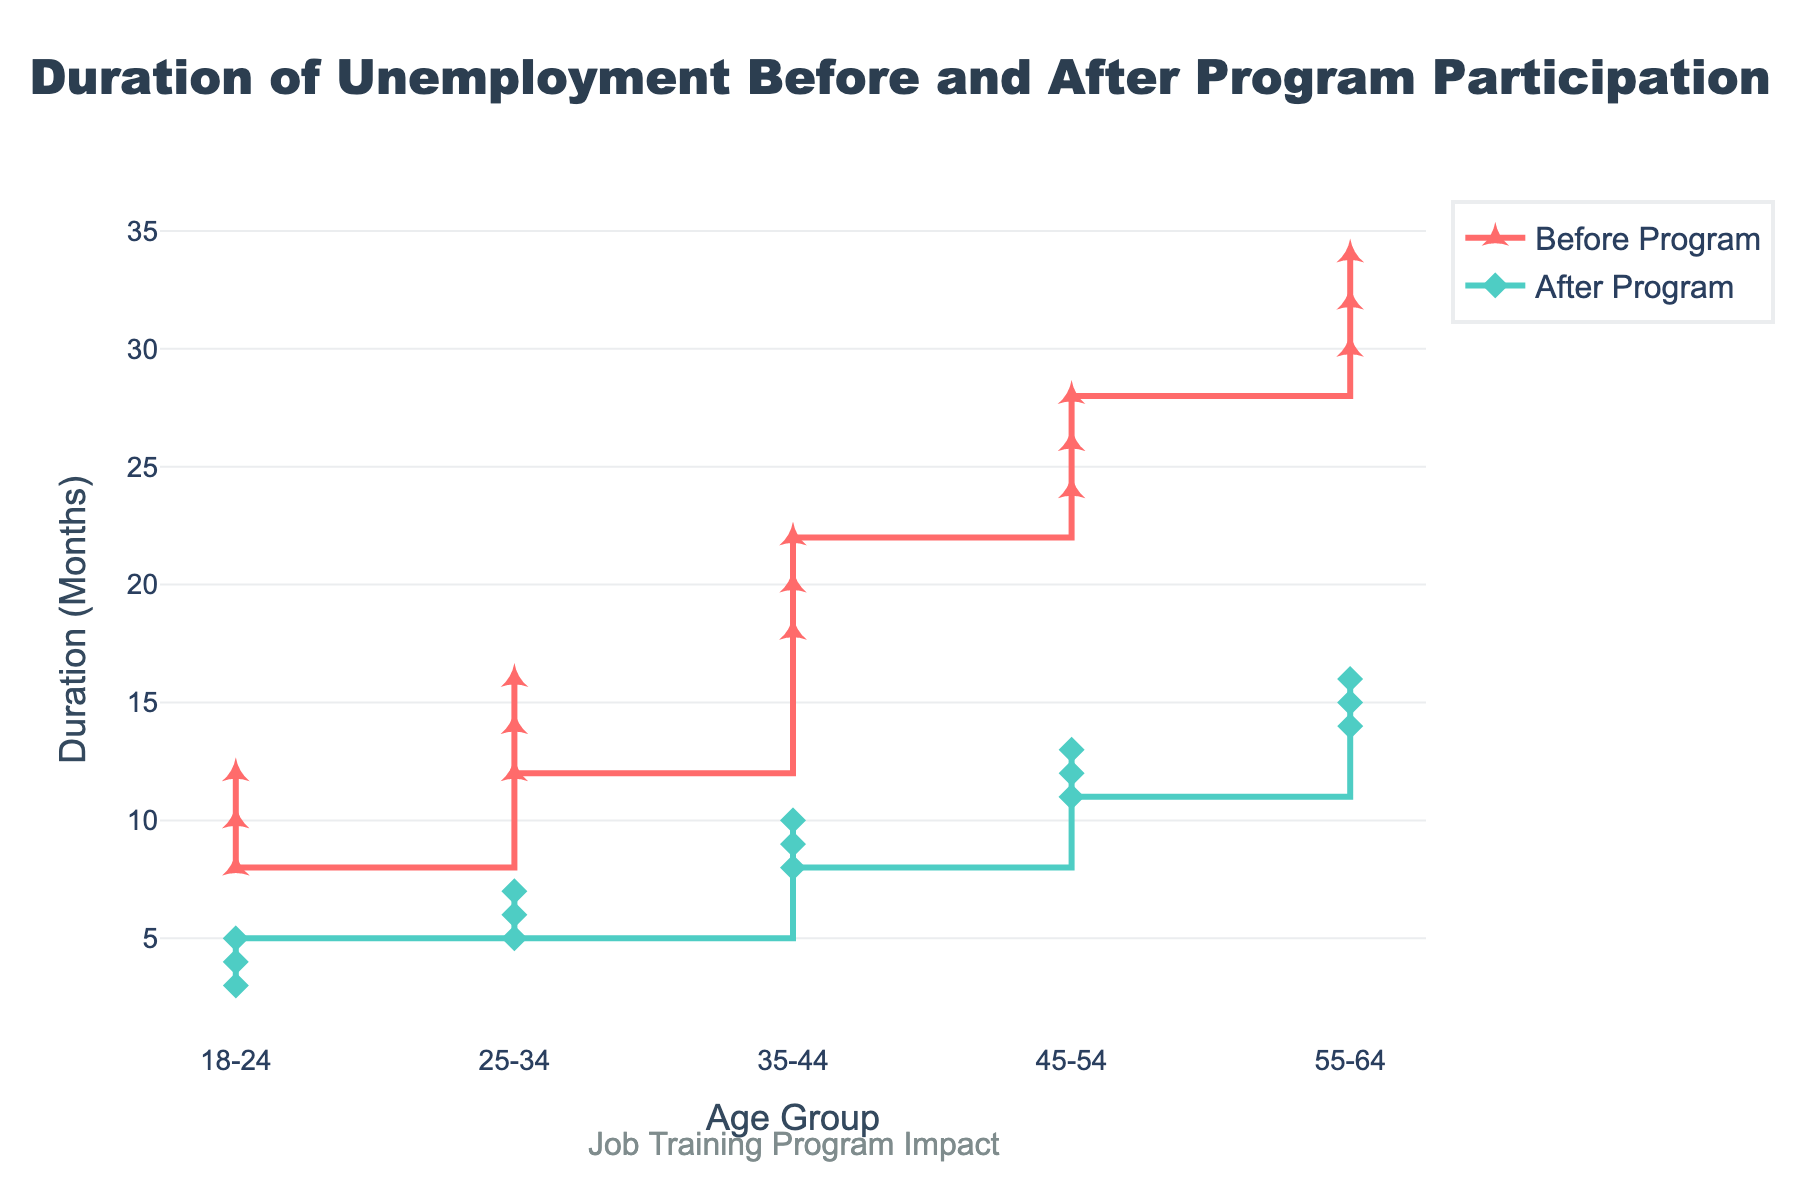What is the title of the figure? The title is usually found at the top of the plot and in this case, it is "Duration of Unemployment Before and After Program Participation."
Answer: Duration of Unemployment Before and After Program Participation Which age group had the longest duration of unemployment before program participation? We look at the "Before Program (Months)" trace and identify the highest value. The age group 55-64 had the longest duration of unemployment before program participation, with values going up to 34 months.
Answer: 55-64 What is the shortest duration of unemployment after program participation for the age group 18-24? We look at the "After Program (Months)" data points for 18-24 and identify the lowest value. The values are 4, 3, and 5 months, making the shortest duration 3 months.
Answer: 3 months By how many months did the duration of unemployment decrease for the age group 25-34 on average? Calculate the difference between "Before Program (Months)" and "After Program (Months)" for each point (14-6, 16-7, 12-5), then find the average. These differences are 8, 9, and 7 months, giving an average of (8+9+7)/3 months, which equals 8 months.
Answer: 8 months Which age group saw the least improvement in unemployment duration after program participation? We compare the differences between "Before Program (Months)" and "After Program (Months)" across all age groups. The age group 18-24 saw decreases of 6, 9, and 3 months; 25-34 saw decreases of 8, 9, and 7; 35-44 saw 9, 10, 14; 45-54 saw 12, 13, 17, and 55-64 saw 16, 14, 19. The least improvement was for the age group 45-54.
Answer: 45-54 What is the median unemployment duration after program participation for the age group 35-44? For the age group 35-44, the "After Program (Months)" values are 9, 10, and 8 months. The median is the middle value in an ordered list. So, the sorted list is 8, 9, 10, making the median 9 months.
Answer: 9 months Compare the change in the duration of unemployment before and after program participation for the age groups 35-44 and 55-64. Which group showed a bigger reduction? First, calculate the differences for each group. For 35-44, the differences are 9 (18-9), 10 (20-10), 14 (22-8), averaging 11 months. For 55-64, the differences are 16 (30-14), 14 (32-16), 19 (34-15), averaging 16.33 months. The age group 55-64 showed a bigger reduction in unemployment duration.
Answer: 55-64 How many data points are there for each age group? Each age group has exactly three data points in the given data.
Answer: 3 